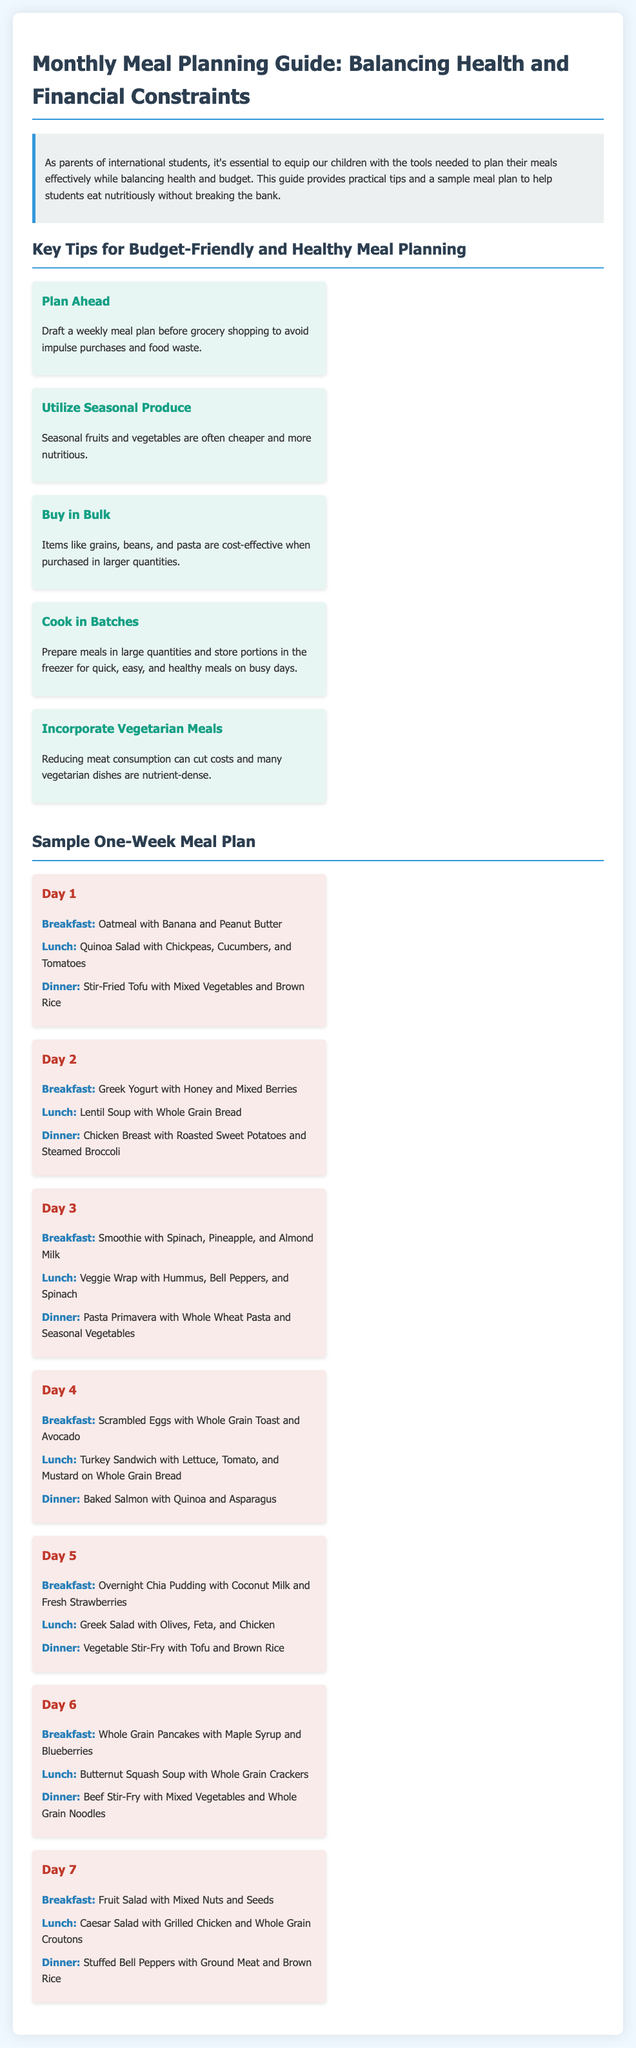what is the title of the document? The title of the document is displayed prominently at the top and is "Monthly Meal Planning Guide: Balancing Health and Financial Constraints."
Answer: Monthly Meal Planning Guide: Balancing Health and Financial Constraints how many tips are provided for budget-friendly meal planning? The document lists a total of five tips for budget-friendly meal planning in the relevant section.
Answer: 5 tips what is the breakfast option for Day 1? The breakfast option for Day 1 is listed under the meal plan section, which is "Oatmeal with Banana and Peanut Butter."
Answer: Oatmeal with Banana and Peanut Butter which day includes a vegetarian dinner option? Two dinner options can be identified as vegetarian - the dinner for Day 1 and Day 5, where the meals consist of Stir-Fried Tofu and Vegetable Stir-Fry, respectively.
Answer: Day 1 and Day 5 what is a key strategy mentioned for saving when buying groceries? One of the key strategies mentioned in the tips section is buying grains, beans, and pasta in larger quantities, referred to as buying in bulk.
Answer: Buy in Bulk which protein-rich food item is included for dinner on Day 4? For dinner on Day 4, "Baked Salmon" is the protein-rich food item mentioned.
Answer: Baked Salmon what is suggested for breakfast on Day 3? The suggested breakfast option for Day 3 is provided as "Smoothie with Spinach, Pineapple, and Almond Milk."
Answer: Smoothie with Spinach, Pineapple, and Almond Milk name one benefit of meal planning according to the document. The benefit indicated in the document relates to avoiding impulse purchases and food waste through effective meal planning prior to grocery shopping.
Answer: Avoiding impulse purchases and food waste 